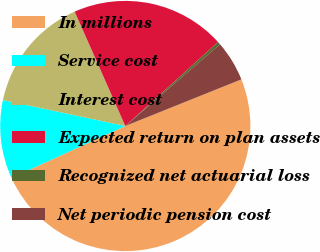Convert chart. <chart><loc_0><loc_0><loc_500><loc_500><pie_chart><fcel>In millions<fcel>Service cost<fcel>Interest cost<fcel>Expected return on plan assets<fcel>Recognized net actuarial loss<fcel>Net periodic pension cost<nl><fcel>49.27%<fcel>10.15%<fcel>15.04%<fcel>19.93%<fcel>0.37%<fcel>5.26%<nl></chart> 